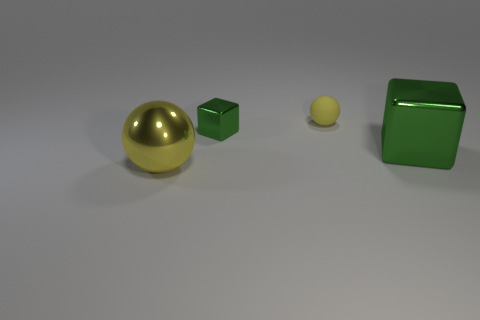Add 1 green metal objects. How many objects exist? 5 Add 3 shiny balls. How many shiny balls are left? 4 Add 3 small yellow rubber spheres. How many small yellow rubber spheres exist? 4 Subtract 0 yellow cylinders. How many objects are left? 4 Subtract all big purple cylinders. Subtract all yellow metal spheres. How many objects are left? 3 